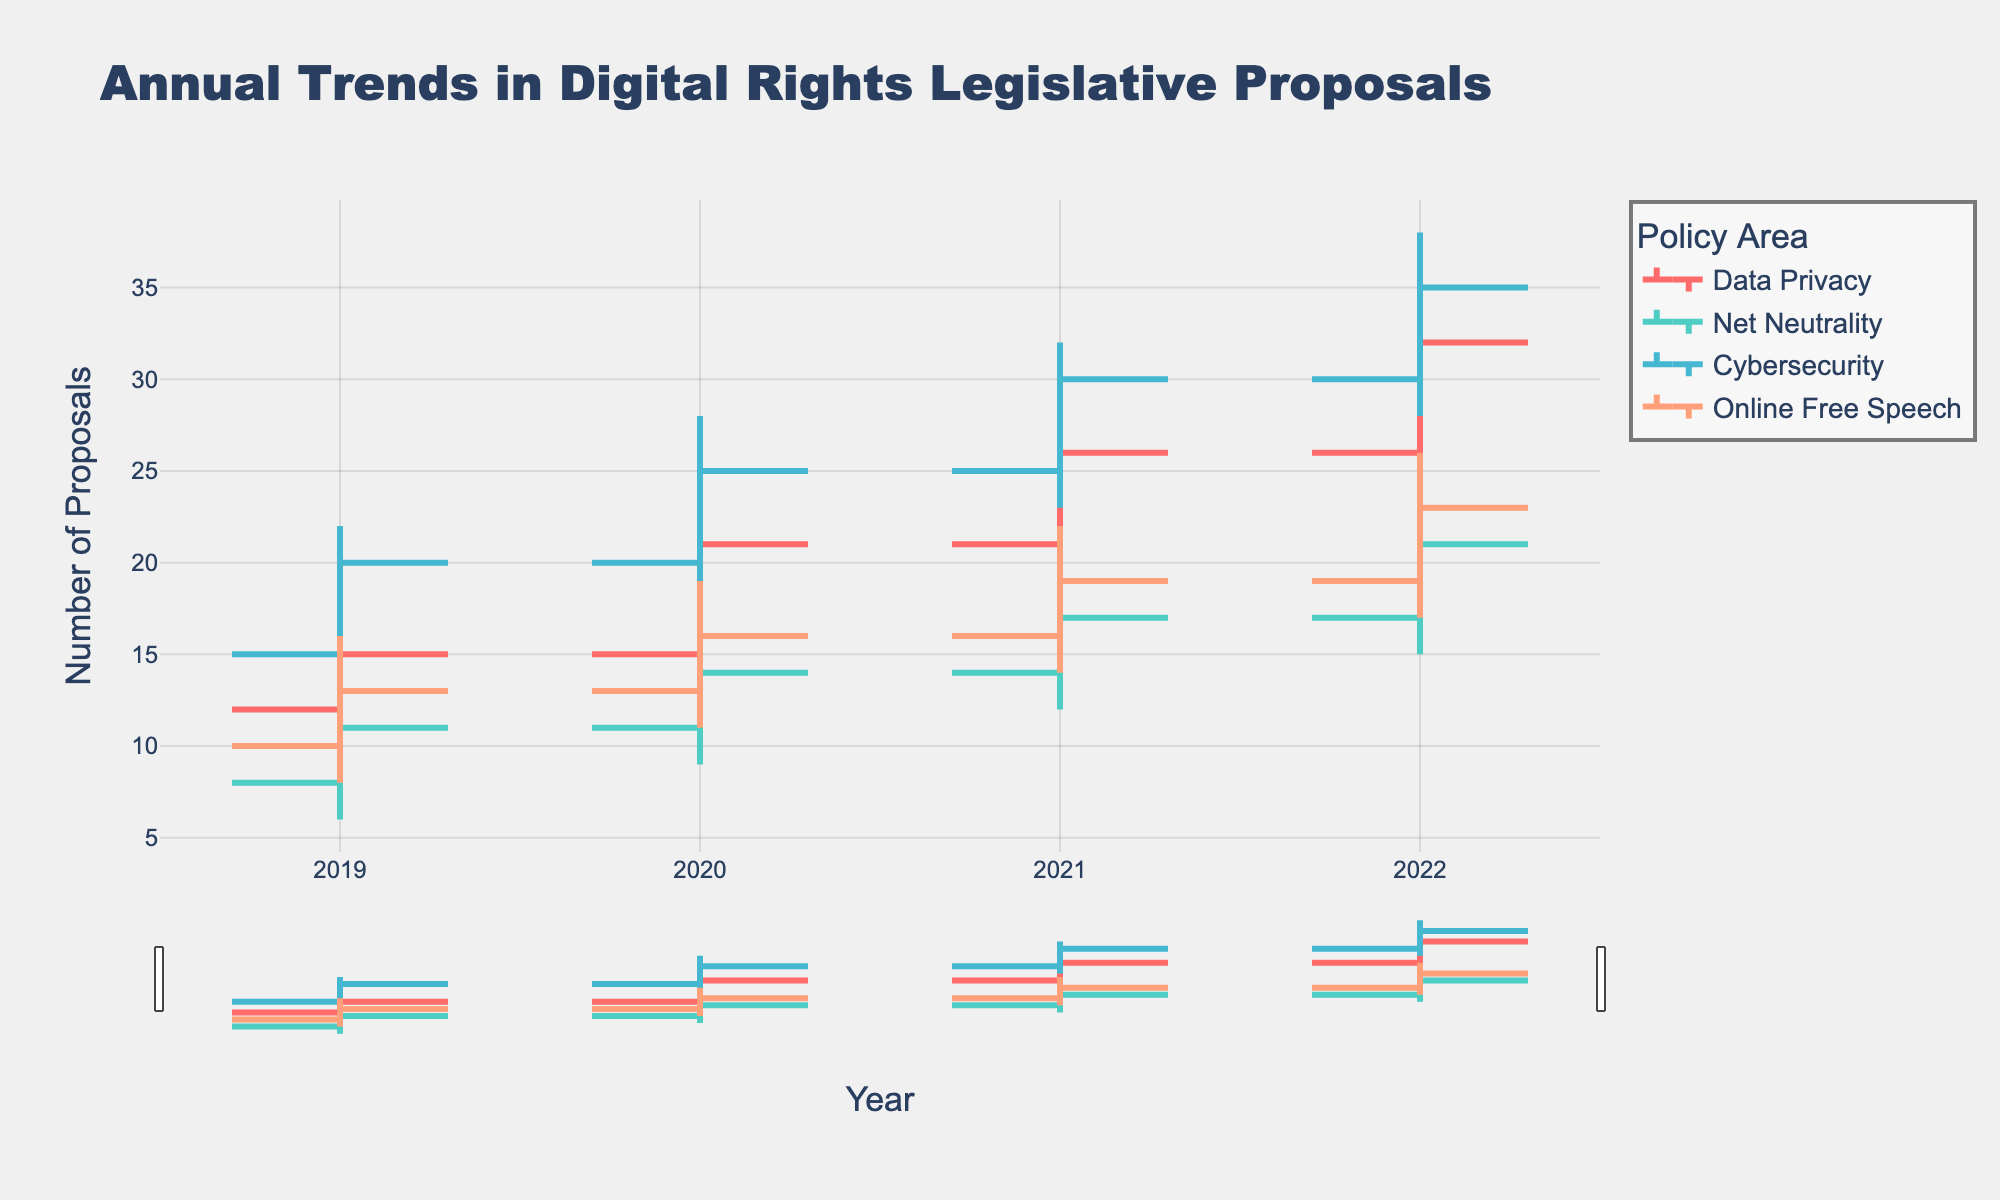How many years of data are presented in the figure? The x-axis runs from 2019 to 2022, indicating that there are 4 years of data presented.
Answer: 4 What is the title of the figure? The title of the figure is written at the top and reads "Annual Trends in Digital Rights Legislative Proposals."
Answer: Annual Trends in Digital Rights Legislative Proposals Which policy area had the highest high value in 2022? In 2022, the highest high value is shown under the "Cybersecurity" policy area at 38.
Answer: Cybersecurity By how much did the closing value of "Net Neutrality" change from 2019 to 2022? The closing value for "Net Neutrality" in 2019 is 11, and in 2022 it is 21. The change is calculated as 21 - 11 = 10.
Answer: 10 In which year was the opening value for "Online Free Speech" closest to its closing value? For "Online Free Speech," the opening and closing values are: 2019 (10 to 13), 2020 (13 to 16), 2021 (16 to 19), and 2022 (19 to 23). The smallest difference is in 2021, with a difference of 3 (19 - 16).
Answer: 2021 Which policy area showed the most consistent increase from 2019 to 2022 in both opening and closing values? Data Privacy, Net Neutrality, and Cybersecurity all increase every year. Data Privacy and Cybersecurity show more consistent increases, but Cybersecurity also exhibits higher increases in both open and close values, especially in closing values.
Answer: Cybersecurity What is the difference between the high and low values for "Data Privacy" in 2021? The high and low values for "Data Privacy" in 2021 are 29 and 19, respectively. The difference is calculated as 29 - 19 = 10.
Answer: 10 How does the median closing value for "Online Free Speech" over the four years compare to the median for "Net Neutrality" over the same period? The closing values for "Online Free Speech" are (13, 16, 19, 23), and for "Net Neutrality" are (11, 14, 17, 21). The medians are calculated as the average of the two middle values: (16+19)/2 = 17.5 for Online Free Speech and (14+17)/2 = 15.5 for Net Neutrality.
Answer: Online Free Speech: 17.5, Net Neutrality: 15.5 What is the cumulative high value for "Data Privacy" across all years? The yearly high values for "Data Privacy" are 18, 23, 29, and 35. The cumulative total is calculated as 18 + 23 + 29 + 35 = 105.
Answer: 105 